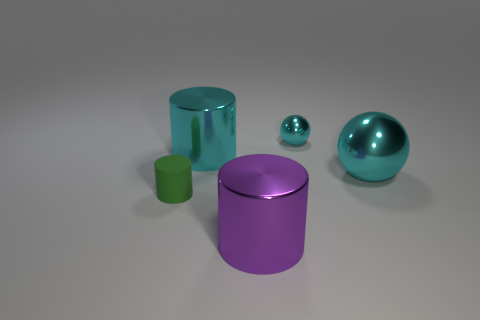Add 3 big purple shiny cylinders. How many objects exist? 8 Subtract all spheres. How many objects are left? 3 Add 3 tiny spheres. How many tiny spheres are left? 4 Add 3 large brown metal balls. How many large brown metal balls exist? 3 Subtract 0 blue spheres. How many objects are left? 5 Subtract all brown metallic cubes. Subtract all tiny metal balls. How many objects are left? 4 